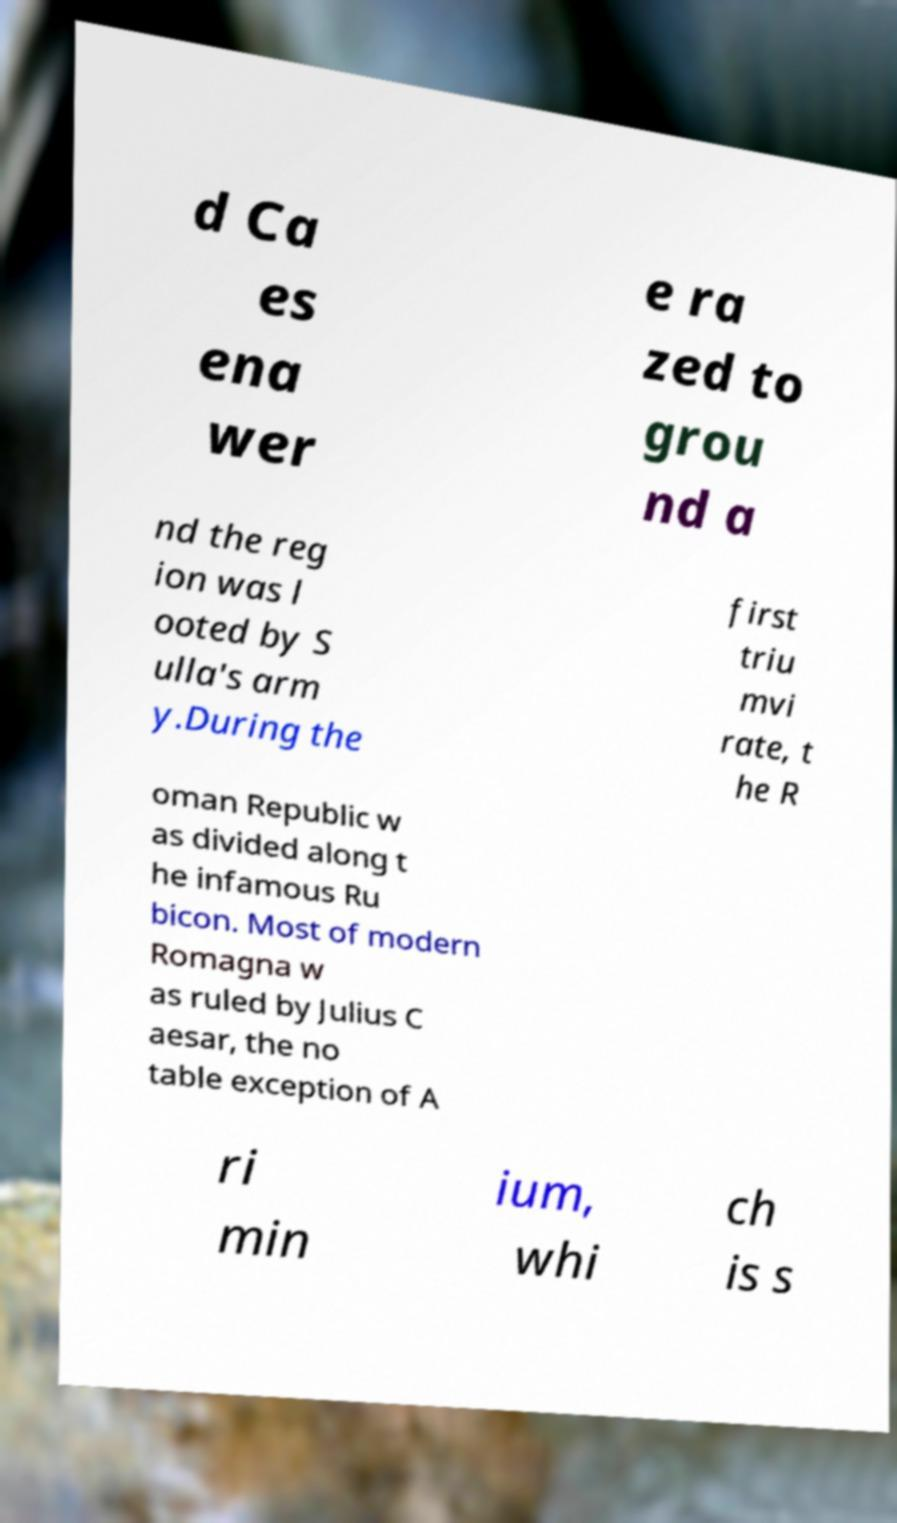For documentation purposes, I need the text within this image transcribed. Could you provide that? d Ca es ena wer e ra zed to grou nd a nd the reg ion was l ooted by S ulla's arm y.During the first triu mvi rate, t he R oman Republic w as divided along t he infamous Ru bicon. Most of modern Romagna w as ruled by Julius C aesar, the no table exception of A ri min ium, whi ch is s 